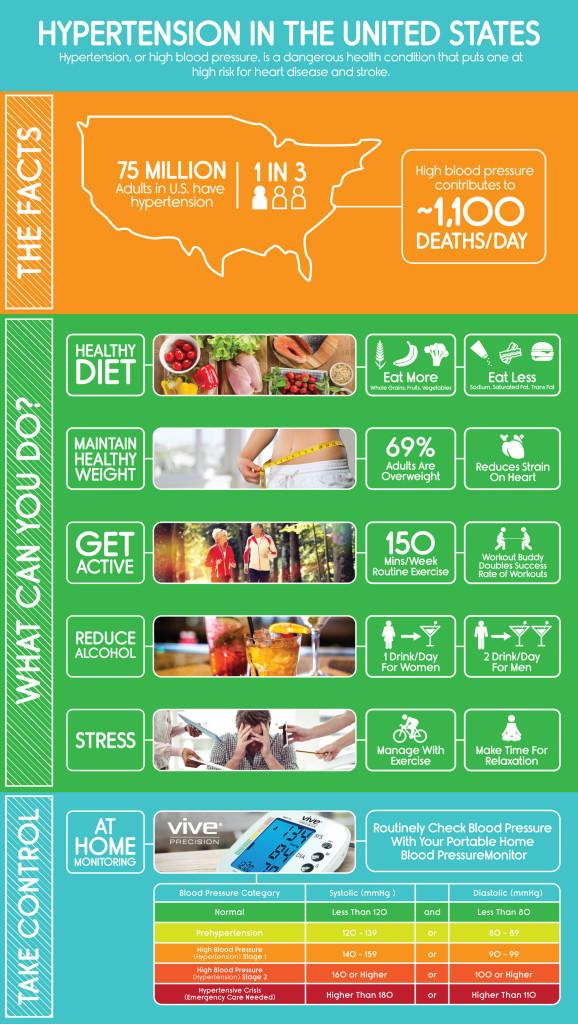Indicate a few pertinent items in this graphic. The highest reading shown in the image of a blood pressure monitor is 134. The diastolic reading, indicated in the third row of the table, is 90-99. There are five categories of blood pressure listed in the table. The number of steps that can be taken to reduce high blood pressure is five. The systolic reading in the fourth row of the table is 160 or higher, indicating that the person may have high blood pressure. 